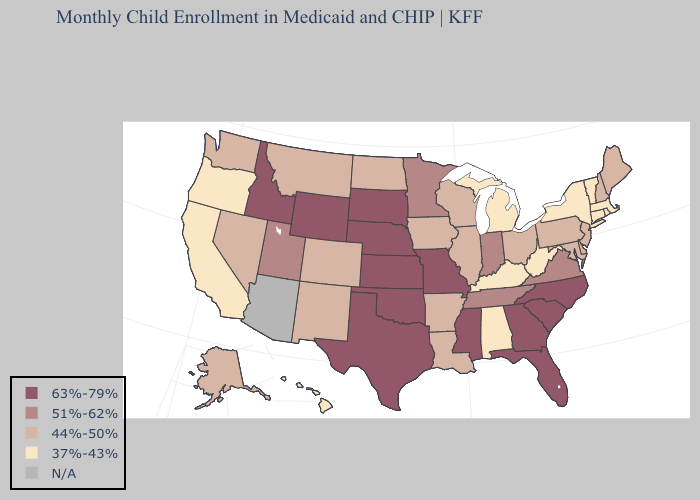How many symbols are there in the legend?
Answer briefly. 5. Does the map have missing data?
Be succinct. Yes. Does Utah have the lowest value in the West?
Give a very brief answer. No. Which states have the lowest value in the Northeast?
Give a very brief answer. Connecticut, Massachusetts, New York, Rhode Island, Vermont. What is the highest value in the MidWest ?
Be succinct. 63%-79%. What is the value of New Mexico?
Write a very short answer. 44%-50%. What is the value of Michigan?
Quick response, please. 37%-43%. Does Mississippi have the highest value in the USA?
Write a very short answer. Yes. Name the states that have a value in the range 44%-50%?
Keep it brief. Alaska, Arkansas, Colorado, Delaware, Illinois, Iowa, Louisiana, Maine, Maryland, Montana, Nevada, New Hampshire, New Jersey, New Mexico, North Dakota, Ohio, Pennsylvania, Washington, Wisconsin. Name the states that have a value in the range 37%-43%?
Answer briefly. Alabama, California, Connecticut, Hawaii, Kentucky, Massachusetts, Michigan, New York, Oregon, Rhode Island, Vermont, West Virginia. What is the lowest value in states that border Colorado?
Short answer required. 44%-50%. Among the states that border North Carolina , does South Carolina have the lowest value?
Short answer required. No. Name the states that have a value in the range 44%-50%?
Answer briefly. Alaska, Arkansas, Colorado, Delaware, Illinois, Iowa, Louisiana, Maine, Maryland, Montana, Nevada, New Hampshire, New Jersey, New Mexico, North Dakota, Ohio, Pennsylvania, Washington, Wisconsin. 